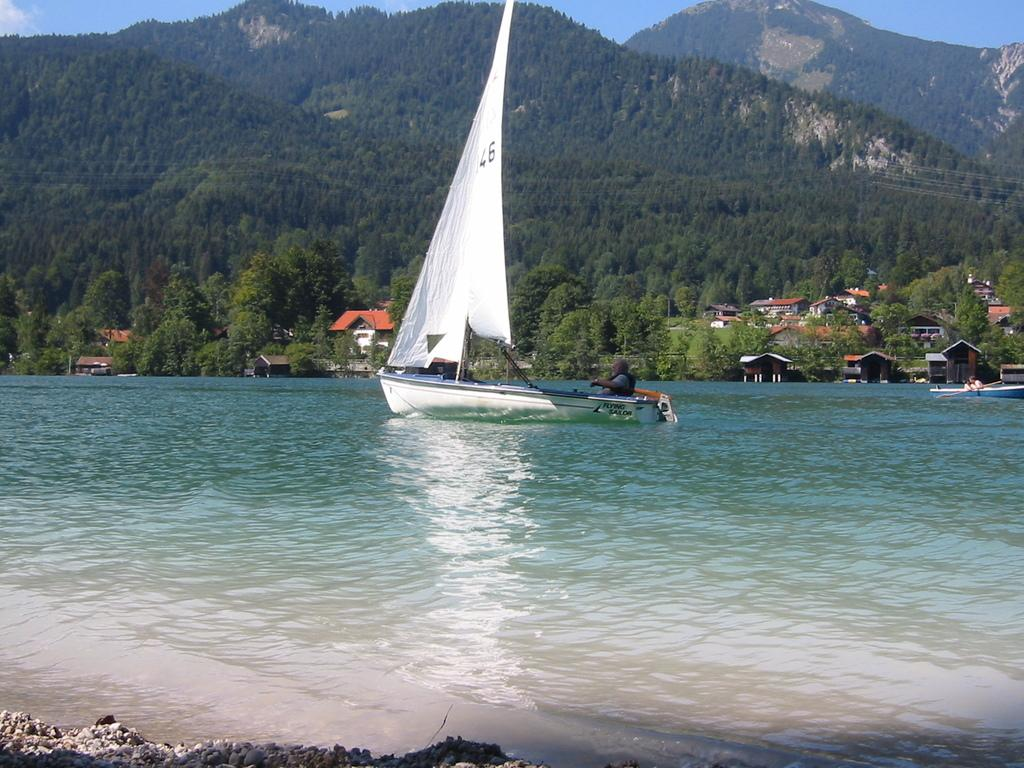What type of vegetation can be seen on the hills in the image? There are trees on the hills in the image. What type of structures are visible in the image? There are houses visible in the image. What can be seen in the water in the image? There are boats in the water in the image. How would you describe the sky in the image? The sky is blue and cloudy in the image. What type of finger can be seen in the image? There is no finger present in the image. What is the mind doing in the image? The concept of a "mind" is not a physical object that can be seen in an image; it refers to the mental processes of a person or animal. 